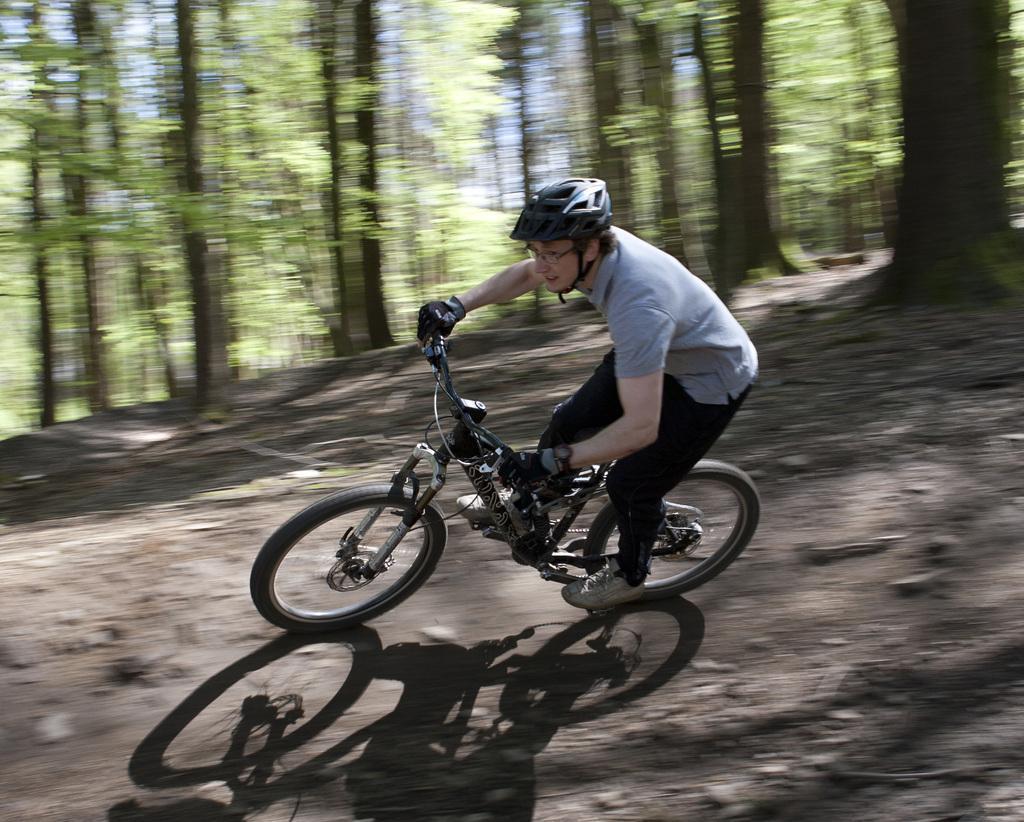How would you summarize this image in a sentence or two? In this image we can see a person wearing helmet and spectacles is riding bicycle. In the background, we can see a group of trees. 